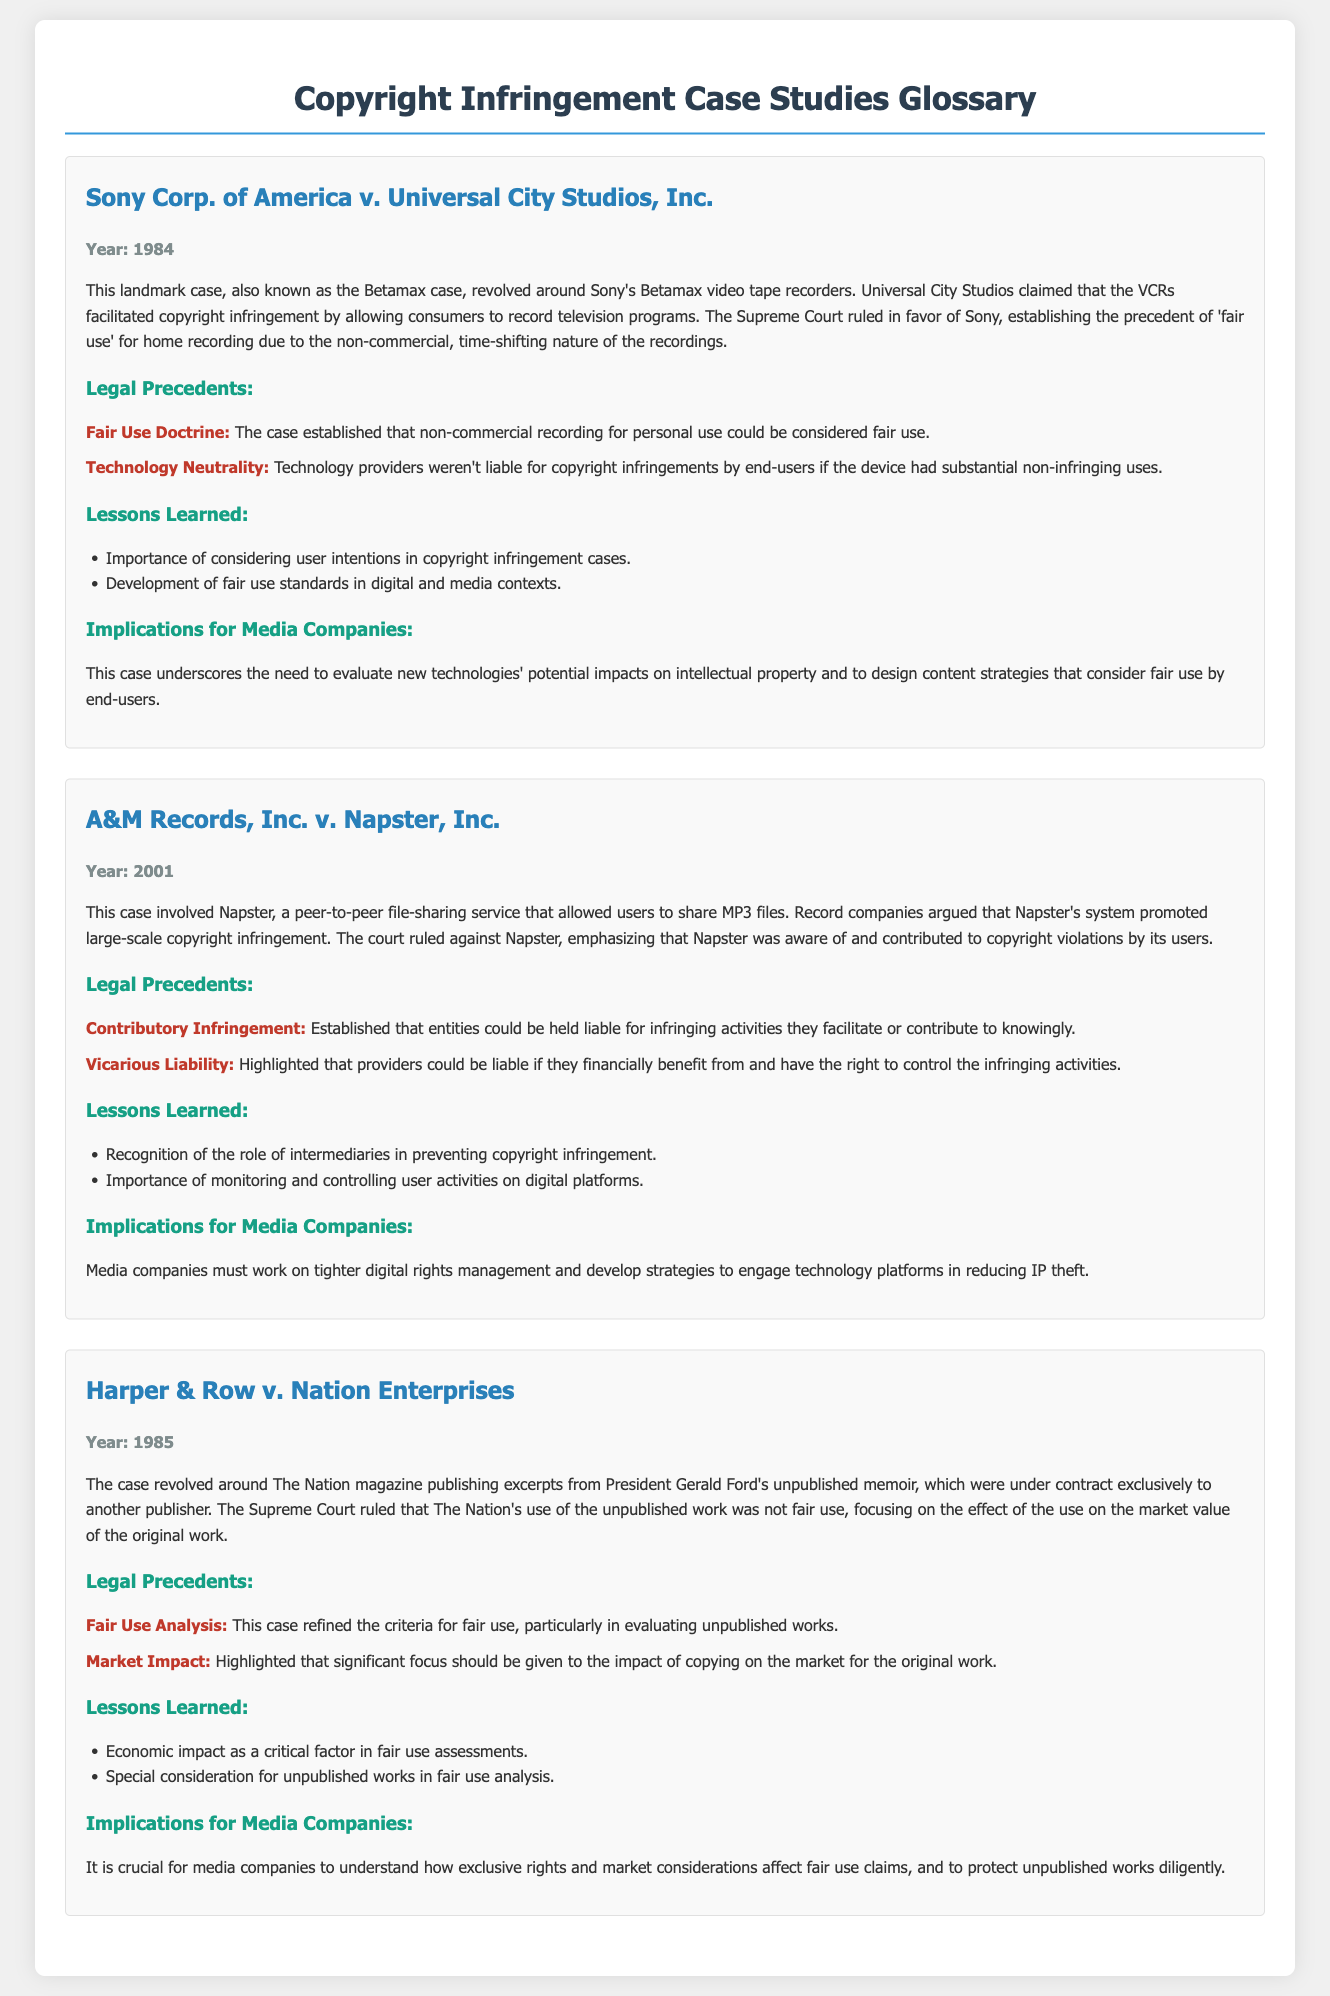What is the first case mentioned? The first case mentioned in the document is "Sony Corp. of America v. Universal City Studios, Inc."
Answer: Sony Corp. of America v. Universal City Studios, Inc What year was the A&M Records case decided? The year the A&M Records case was decided is noted as 2001 in the document.
Answer: 2001 What was the ruling in the Harper & Row case? The ruling in the Harper & Row case determined that The Nation's use was not fair use due to its impact on market value.
Answer: Not fair use What legal precedent was established in the Sony case? The case established the "Fair Use Doctrine" which states that non-commercial recording for personal use could be considered fair use.
Answer: Fair Use Doctrine What major lesson was learned from the Napster case? A major lesson learned from the Napster case is the importance of monitoring and controlling user activities on digital platforms.
Answer: Importance of monitoring user activities What is a key implication of the Harper & Row case for media companies? A key implication for media companies from the Harper & Row case is the need to understand how exclusive rights and market considerations affect fair use claims.
Answer: Understand exclusive rights and market considerations How many legal precedents are listed for the Napster case? The document lists two legal precedents for the Napster case.
Answer: Two What does the term "Vicarious Liability" refer to in the Napster case? "Vicarious Liability" refers to providers being liable if they financially benefit from and have the right to control the infringing activities.
Answer: Liability for financial benefit and control 